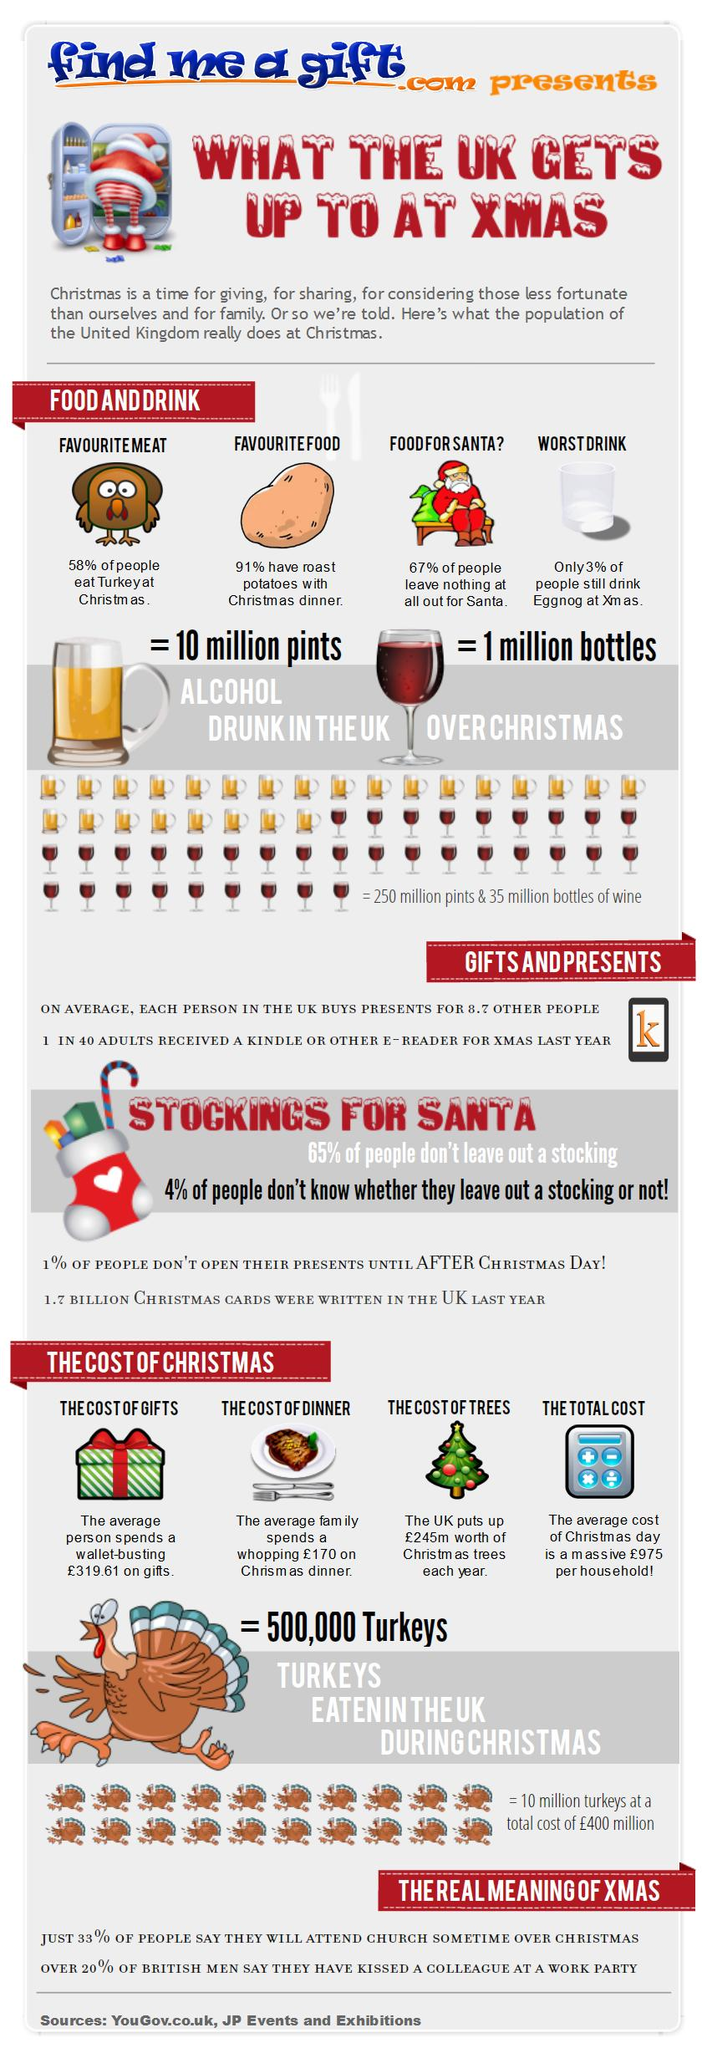Identify some key points in this picture. According to a survey, approximately 42% of people do not eat turkey at Christmas. According to a survey, 67% of people do not leave anything out for Santa. The text "find me a gift" is written in blue. The infographics under the topic "the cost of Christmas" discuss various types of costs apart from the total cost, such as the cost of gifts, the cost of dinner, and the cost of trees. The infographic contains 22 vector images of turkeys. 